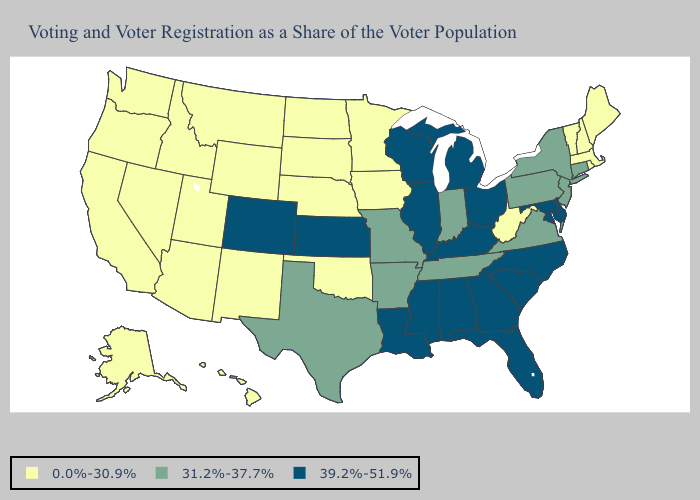Name the states that have a value in the range 39.2%-51.9%?
Write a very short answer. Alabama, Colorado, Delaware, Florida, Georgia, Illinois, Kansas, Kentucky, Louisiana, Maryland, Michigan, Mississippi, North Carolina, Ohio, South Carolina, Wisconsin. Does Nebraska have the lowest value in the USA?
Keep it brief. Yes. Name the states that have a value in the range 0.0%-30.9%?
Concise answer only. Alaska, Arizona, California, Hawaii, Idaho, Iowa, Maine, Massachusetts, Minnesota, Montana, Nebraska, Nevada, New Hampshire, New Mexico, North Dakota, Oklahoma, Oregon, Rhode Island, South Dakota, Utah, Vermont, Washington, West Virginia, Wyoming. Name the states that have a value in the range 39.2%-51.9%?
Quick response, please. Alabama, Colorado, Delaware, Florida, Georgia, Illinois, Kansas, Kentucky, Louisiana, Maryland, Michigan, Mississippi, North Carolina, Ohio, South Carolina, Wisconsin. What is the lowest value in the South?
Write a very short answer. 0.0%-30.9%. Which states have the highest value in the USA?
Concise answer only. Alabama, Colorado, Delaware, Florida, Georgia, Illinois, Kansas, Kentucky, Louisiana, Maryland, Michigan, Mississippi, North Carolina, Ohio, South Carolina, Wisconsin. Name the states that have a value in the range 31.2%-37.7%?
Quick response, please. Arkansas, Connecticut, Indiana, Missouri, New Jersey, New York, Pennsylvania, Tennessee, Texas, Virginia. Name the states that have a value in the range 0.0%-30.9%?
Be succinct. Alaska, Arizona, California, Hawaii, Idaho, Iowa, Maine, Massachusetts, Minnesota, Montana, Nebraska, Nevada, New Hampshire, New Mexico, North Dakota, Oklahoma, Oregon, Rhode Island, South Dakota, Utah, Vermont, Washington, West Virginia, Wyoming. Does Connecticut have the highest value in the Northeast?
Short answer required. Yes. What is the value of Utah?
Short answer required. 0.0%-30.9%. Name the states that have a value in the range 39.2%-51.9%?
Answer briefly. Alabama, Colorado, Delaware, Florida, Georgia, Illinois, Kansas, Kentucky, Louisiana, Maryland, Michigan, Mississippi, North Carolina, Ohio, South Carolina, Wisconsin. Does West Virginia have a lower value than North Carolina?
Answer briefly. Yes. What is the highest value in the South ?
Answer briefly. 39.2%-51.9%. What is the highest value in the MidWest ?
Answer briefly. 39.2%-51.9%. 